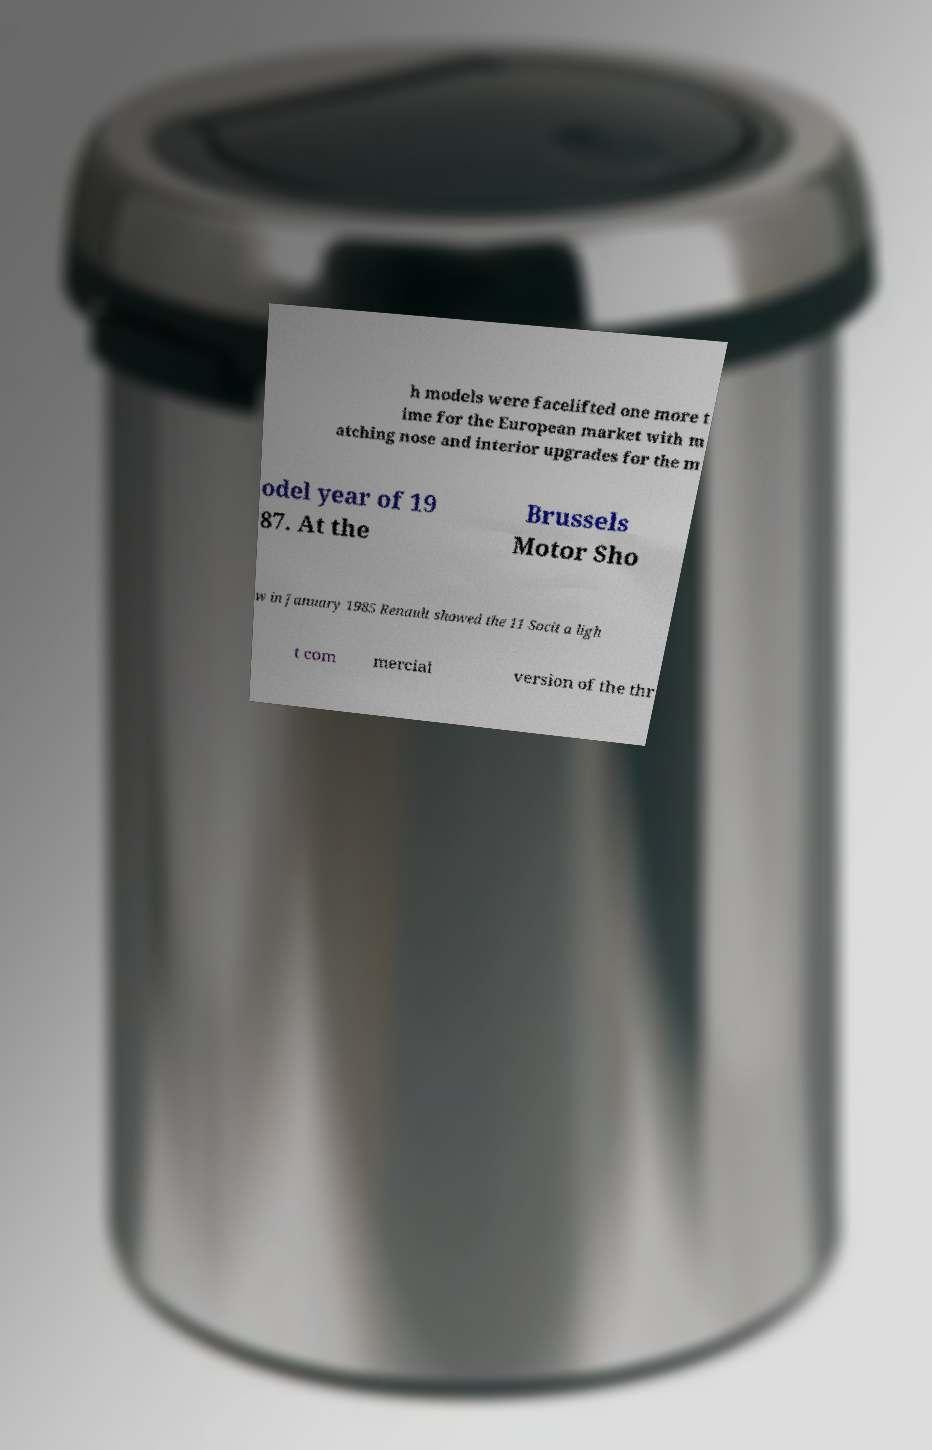Please identify and transcribe the text found in this image. h models were facelifted one more t ime for the European market with m atching nose and interior upgrades for the m odel year of 19 87. At the Brussels Motor Sho w in January 1985 Renault showed the 11 Socit a ligh t com mercial version of the thr 